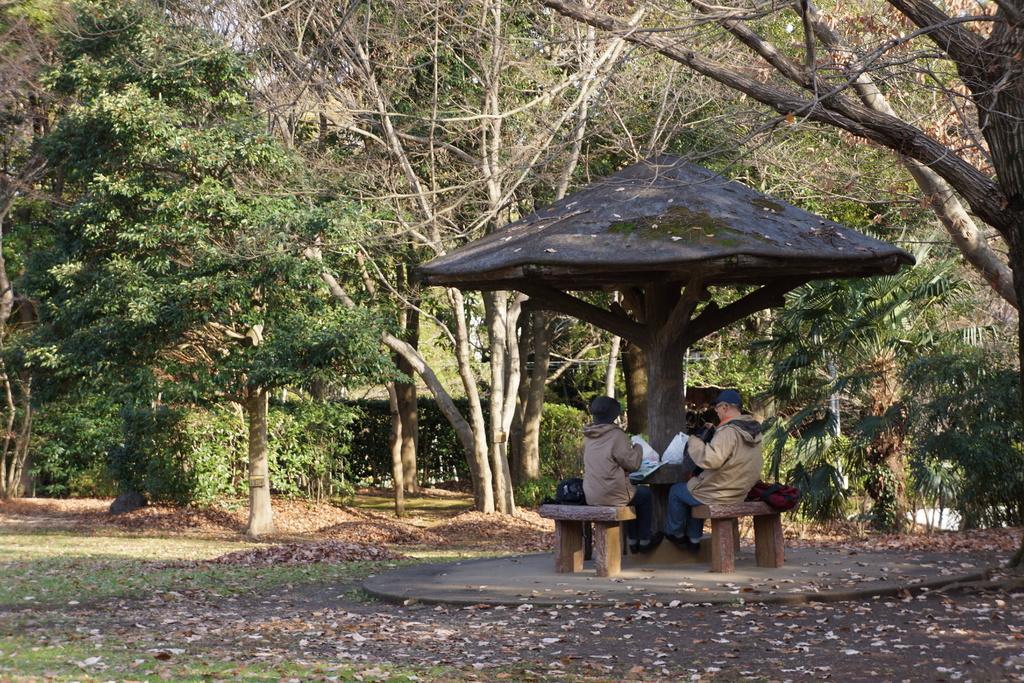Could you give a brief overview of what you see in this image? On the right side we can see two persons are sitting on the platforms under a tent and they are holding objects in their hands and there are bags on the platforms. In the background there are trees, grass and leaves on the ground. 